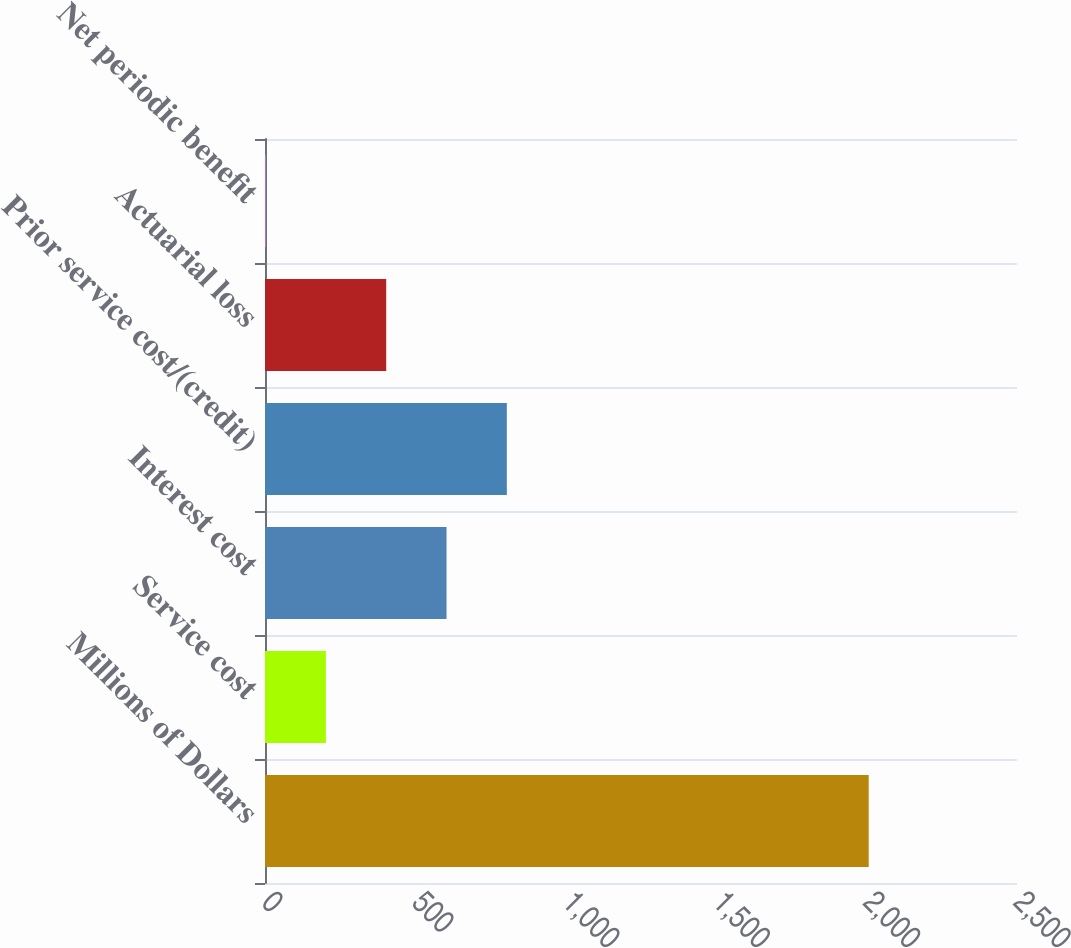Convert chart to OTSL. <chart><loc_0><loc_0><loc_500><loc_500><bar_chart><fcel>Millions of Dollars<fcel>Service cost<fcel>Interest cost<fcel>Prior service cost/(credit)<fcel>Actuarial loss<fcel>Net periodic benefit<nl><fcel>2007<fcel>202.5<fcel>603.5<fcel>804<fcel>403<fcel>2<nl></chart> 